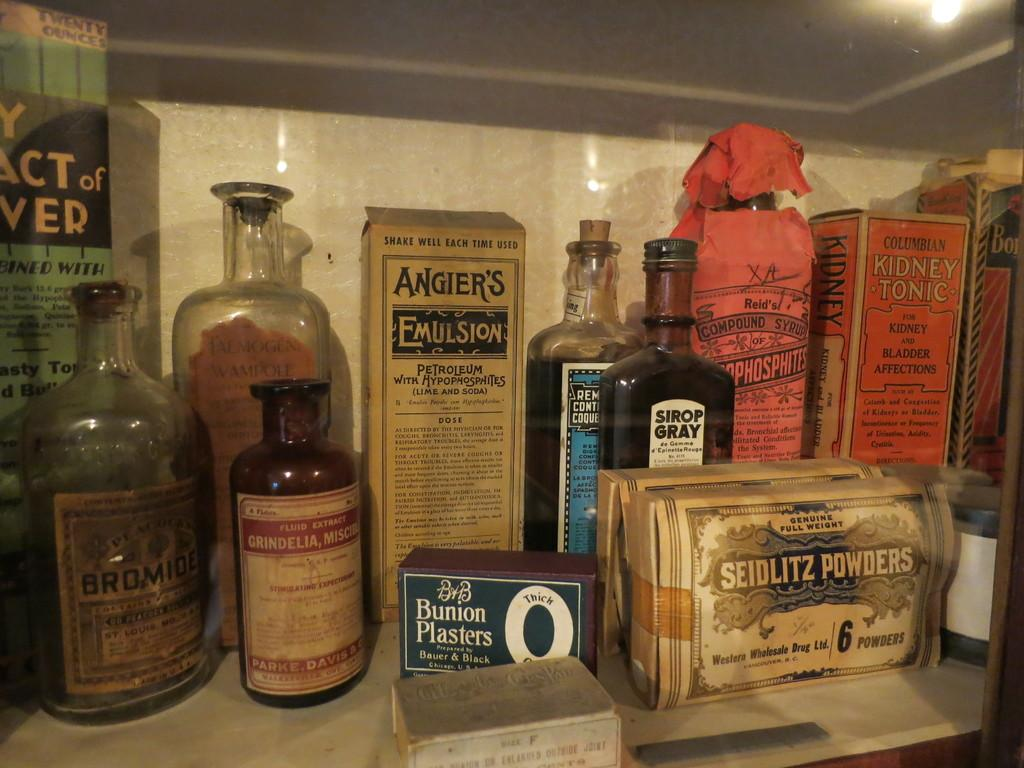<image>
Give a short and clear explanation of the subsequent image. A shelf full of bottles and boxes including a box of Angier's Emulsion. 